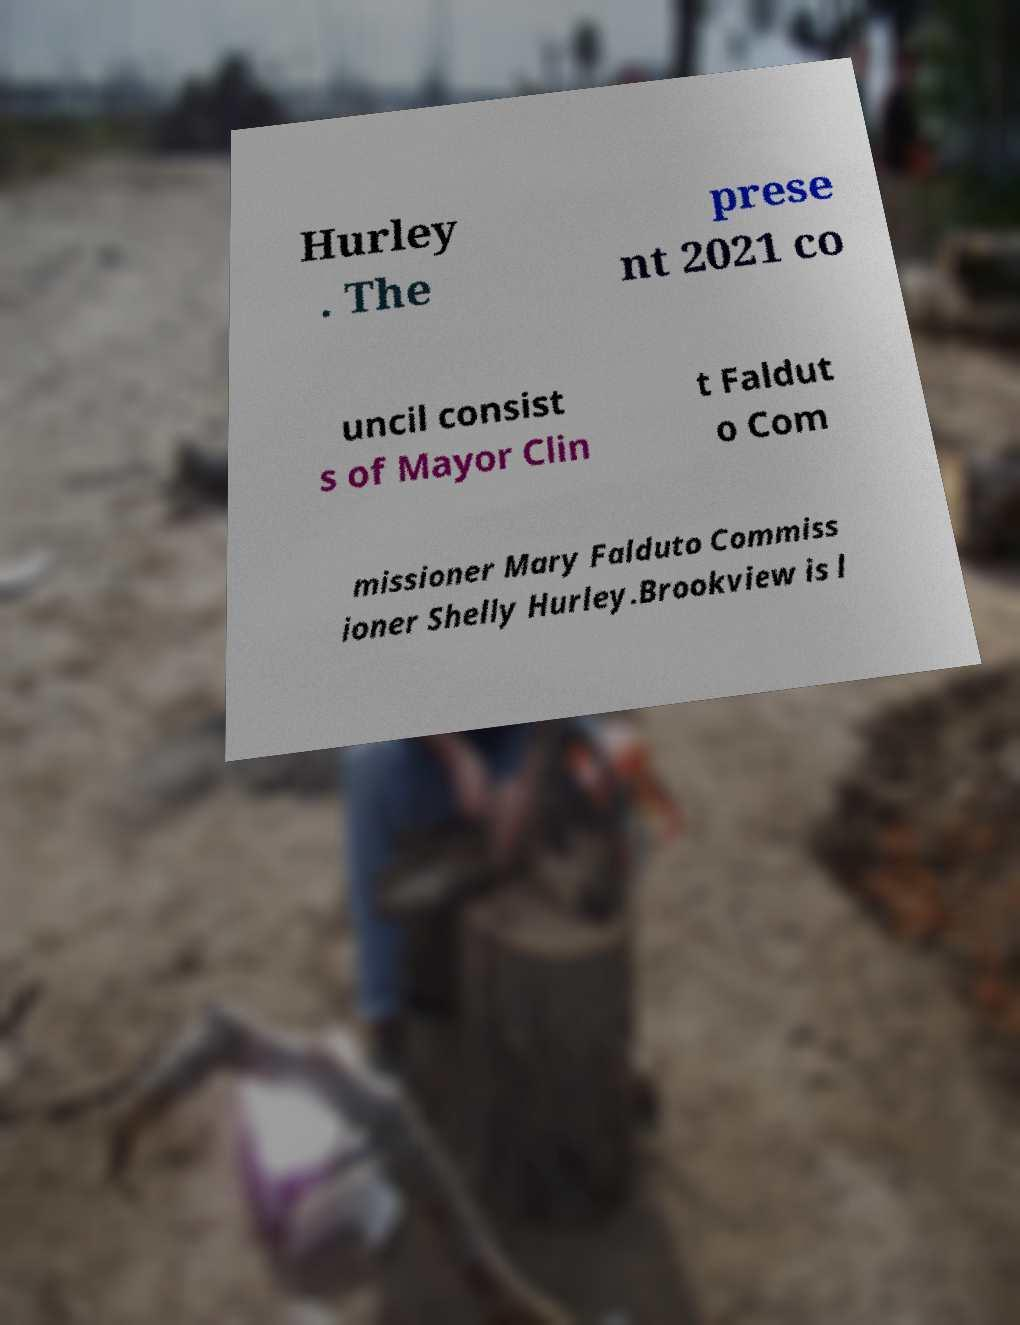Please read and relay the text visible in this image. What does it say? Hurley . The prese nt 2021 co uncil consist s of Mayor Clin t Faldut o Com missioner Mary Falduto Commiss ioner Shelly Hurley.Brookview is l 